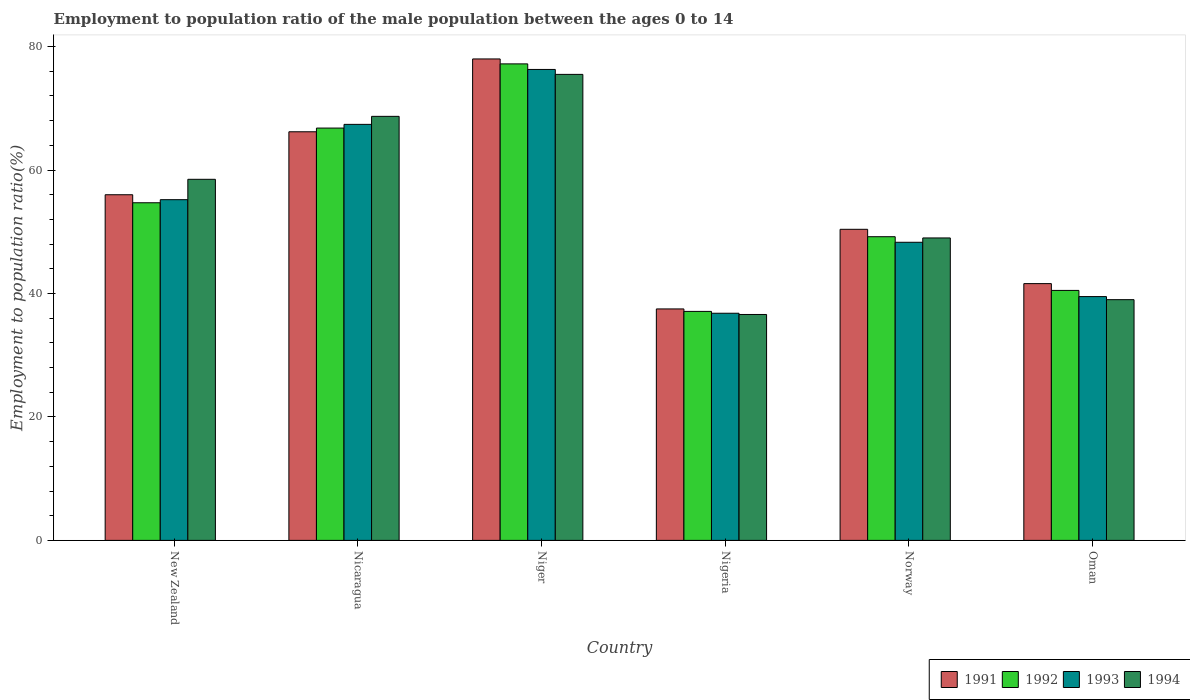How many different coloured bars are there?
Make the answer very short. 4. Are the number of bars per tick equal to the number of legend labels?
Keep it short and to the point. Yes. Are the number of bars on each tick of the X-axis equal?
Your answer should be very brief. Yes. How many bars are there on the 6th tick from the right?
Your response must be concise. 4. What is the label of the 2nd group of bars from the left?
Your response must be concise. Nicaragua. Across all countries, what is the maximum employment to population ratio in 1994?
Give a very brief answer. 75.5. Across all countries, what is the minimum employment to population ratio in 1994?
Your answer should be compact. 36.6. In which country was the employment to population ratio in 1994 maximum?
Keep it short and to the point. Niger. In which country was the employment to population ratio in 1994 minimum?
Your answer should be compact. Nigeria. What is the total employment to population ratio in 1994 in the graph?
Ensure brevity in your answer.  327.3. What is the difference between the employment to population ratio in 1993 in New Zealand and that in Oman?
Make the answer very short. 15.7. What is the difference between the employment to population ratio in 1993 in Nigeria and the employment to population ratio in 1991 in Oman?
Keep it short and to the point. -4.8. What is the average employment to population ratio in 1993 per country?
Your answer should be very brief. 53.92. What is the difference between the employment to population ratio of/in 1991 and employment to population ratio of/in 1993 in Nigeria?
Give a very brief answer. 0.7. What is the ratio of the employment to population ratio in 1993 in Niger to that in Oman?
Offer a terse response. 1.93. What is the difference between the highest and the second highest employment to population ratio in 1992?
Ensure brevity in your answer.  -10.4. What is the difference between the highest and the lowest employment to population ratio in 1993?
Keep it short and to the point. 39.5. In how many countries, is the employment to population ratio in 1994 greater than the average employment to population ratio in 1994 taken over all countries?
Provide a succinct answer. 3. What does the 1st bar from the left in Nicaragua represents?
Offer a very short reply. 1991. Is it the case that in every country, the sum of the employment to population ratio in 1992 and employment to population ratio in 1993 is greater than the employment to population ratio in 1991?
Your answer should be very brief. Yes. How many bars are there?
Make the answer very short. 24. Are all the bars in the graph horizontal?
Keep it short and to the point. No. How many countries are there in the graph?
Provide a succinct answer. 6. How many legend labels are there?
Your answer should be very brief. 4. What is the title of the graph?
Make the answer very short. Employment to population ratio of the male population between the ages 0 to 14. What is the label or title of the X-axis?
Provide a short and direct response. Country. What is the Employment to population ratio(%) in 1992 in New Zealand?
Offer a very short reply. 54.7. What is the Employment to population ratio(%) in 1993 in New Zealand?
Your answer should be compact. 55.2. What is the Employment to population ratio(%) of 1994 in New Zealand?
Your answer should be compact. 58.5. What is the Employment to population ratio(%) of 1991 in Nicaragua?
Your answer should be compact. 66.2. What is the Employment to population ratio(%) in 1992 in Nicaragua?
Make the answer very short. 66.8. What is the Employment to population ratio(%) of 1993 in Nicaragua?
Offer a terse response. 67.4. What is the Employment to population ratio(%) of 1994 in Nicaragua?
Your answer should be very brief. 68.7. What is the Employment to population ratio(%) of 1991 in Niger?
Your response must be concise. 78. What is the Employment to population ratio(%) in 1992 in Niger?
Your answer should be compact. 77.2. What is the Employment to population ratio(%) of 1993 in Niger?
Ensure brevity in your answer.  76.3. What is the Employment to population ratio(%) in 1994 in Niger?
Ensure brevity in your answer.  75.5. What is the Employment to population ratio(%) in 1991 in Nigeria?
Make the answer very short. 37.5. What is the Employment to population ratio(%) in 1992 in Nigeria?
Your answer should be compact. 37.1. What is the Employment to population ratio(%) in 1993 in Nigeria?
Keep it short and to the point. 36.8. What is the Employment to population ratio(%) of 1994 in Nigeria?
Give a very brief answer. 36.6. What is the Employment to population ratio(%) in 1991 in Norway?
Your response must be concise. 50.4. What is the Employment to population ratio(%) of 1992 in Norway?
Your answer should be compact. 49.2. What is the Employment to population ratio(%) of 1993 in Norway?
Ensure brevity in your answer.  48.3. What is the Employment to population ratio(%) in 1994 in Norway?
Offer a very short reply. 49. What is the Employment to population ratio(%) of 1991 in Oman?
Provide a short and direct response. 41.6. What is the Employment to population ratio(%) in 1992 in Oman?
Your answer should be compact. 40.5. What is the Employment to population ratio(%) of 1993 in Oman?
Your response must be concise. 39.5. What is the Employment to population ratio(%) in 1994 in Oman?
Provide a succinct answer. 39. Across all countries, what is the maximum Employment to population ratio(%) of 1991?
Offer a very short reply. 78. Across all countries, what is the maximum Employment to population ratio(%) in 1992?
Your answer should be very brief. 77.2. Across all countries, what is the maximum Employment to population ratio(%) in 1993?
Your answer should be very brief. 76.3. Across all countries, what is the maximum Employment to population ratio(%) of 1994?
Offer a terse response. 75.5. Across all countries, what is the minimum Employment to population ratio(%) in 1991?
Make the answer very short. 37.5. Across all countries, what is the minimum Employment to population ratio(%) in 1992?
Ensure brevity in your answer.  37.1. Across all countries, what is the minimum Employment to population ratio(%) in 1993?
Make the answer very short. 36.8. Across all countries, what is the minimum Employment to population ratio(%) of 1994?
Give a very brief answer. 36.6. What is the total Employment to population ratio(%) in 1991 in the graph?
Your answer should be compact. 329.7. What is the total Employment to population ratio(%) of 1992 in the graph?
Make the answer very short. 325.5. What is the total Employment to population ratio(%) in 1993 in the graph?
Provide a short and direct response. 323.5. What is the total Employment to population ratio(%) of 1994 in the graph?
Offer a very short reply. 327.3. What is the difference between the Employment to population ratio(%) of 1992 in New Zealand and that in Nicaragua?
Your answer should be very brief. -12.1. What is the difference between the Employment to population ratio(%) in 1993 in New Zealand and that in Nicaragua?
Keep it short and to the point. -12.2. What is the difference between the Employment to population ratio(%) of 1994 in New Zealand and that in Nicaragua?
Provide a succinct answer. -10.2. What is the difference between the Employment to population ratio(%) in 1992 in New Zealand and that in Niger?
Your answer should be very brief. -22.5. What is the difference between the Employment to population ratio(%) in 1993 in New Zealand and that in Niger?
Your response must be concise. -21.1. What is the difference between the Employment to population ratio(%) in 1994 in New Zealand and that in Nigeria?
Your response must be concise. 21.9. What is the difference between the Employment to population ratio(%) of 1993 in New Zealand and that in Norway?
Offer a terse response. 6.9. What is the difference between the Employment to population ratio(%) in 1994 in New Zealand and that in Norway?
Offer a very short reply. 9.5. What is the difference between the Employment to population ratio(%) of 1992 in New Zealand and that in Oman?
Your answer should be very brief. 14.2. What is the difference between the Employment to population ratio(%) of 1993 in New Zealand and that in Oman?
Keep it short and to the point. 15.7. What is the difference between the Employment to population ratio(%) of 1993 in Nicaragua and that in Niger?
Provide a succinct answer. -8.9. What is the difference between the Employment to population ratio(%) of 1994 in Nicaragua and that in Niger?
Your answer should be compact. -6.8. What is the difference between the Employment to population ratio(%) of 1991 in Nicaragua and that in Nigeria?
Keep it short and to the point. 28.7. What is the difference between the Employment to population ratio(%) of 1992 in Nicaragua and that in Nigeria?
Provide a short and direct response. 29.7. What is the difference between the Employment to population ratio(%) in 1993 in Nicaragua and that in Nigeria?
Offer a terse response. 30.6. What is the difference between the Employment to population ratio(%) of 1994 in Nicaragua and that in Nigeria?
Offer a very short reply. 32.1. What is the difference between the Employment to population ratio(%) in 1991 in Nicaragua and that in Norway?
Offer a terse response. 15.8. What is the difference between the Employment to population ratio(%) of 1993 in Nicaragua and that in Norway?
Your answer should be compact. 19.1. What is the difference between the Employment to population ratio(%) of 1994 in Nicaragua and that in Norway?
Offer a terse response. 19.7. What is the difference between the Employment to population ratio(%) of 1991 in Nicaragua and that in Oman?
Give a very brief answer. 24.6. What is the difference between the Employment to population ratio(%) of 1992 in Nicaragua and that in Oman?
Offer a very short reply. 26.3. What is the difference between the Employment to population ratio(%) in 1993 in Nicaragua and that in Oman?
Your answer should be compact. 27.9. What is the difference between the Employment to population ratio(%) of 1994 in Nicaragua and that in Oman?
Give a very brief answer. 29.7. What is the difference between the Employment to population ratio(%) of 1991 in Niger and that in Nigeria?
Keep it short and to the point. 40.5. What is the difference between the Employment to population ratio(%) of 1992 in Niger and that in Nigeria?
Keep it short and to the point. 40.1. What is the difference between the Employment to population ratio(%) in 1993 in Niger and that in Nigeria?
Provide a succinct answer. 39.5. What is the difference between the Employment to population ratio(%) in 1994 in Niger and that in Nigeria?
Make the answer very short. 38.9. What is the difference between the Employment to population ratio(%) in 1991 in Niger and that in Norway?
Offer a very short reply. 27.6. What is the difference between the Employment to population ratio(%) in 1994 in Niger and that in Norway?
Offer a very short reply. 26.5. What is the difference between the Employment to population ratio(%) of 1991 in Niger and that in Oman?
Keep it short and to the point. 36.4. What is the difference between the Employment to population ratio(%) in 1992 in Niger and that in Oman?
Provide a succinct answer. 36.7. What is the difference between the Employment to population ratio(%) in 1993 in Niger and that in Oman?
Your response must be concise. 36.8. What is the difference between the Employment to population ratio(%) of 1994 in Niger and that in Oman?
Give a very brief answer. 36.5. What is the difference between the Employment to population ratio(%) of 1991 in Nigeria and that in Norway?
Your answer should be compact. -12.9. What is the difference between the Employment to population ratio(%) in 1992 in Nigeria and that in Norway?
Your response must be concise. -12.1. What is the difference between the Employment to population ratio(%) of 1991 in Nigeria and that in Oman?
Offer a very short reply. -4.1. What is the difference between the Employment to population ratio(%) in 1992 in Nigeria and that in Oman?
Offer a very short reply. -3.4. What is the difference between the Employment to population ratio(%) in 1993 in Norway and that in Oman?
Your response must be concise. 8.8. What is the difference between the Employment to population ratio(%) in 1994 in Norway and that in Oman?
Keep it short and to the point. 10. What is the difference between the Employment to population ratio(%) of 1991 in New Zealand and the Employment to population ratio(%) of 1992 in Nicaragua?
Offer a terse response. -10.8. What is the difference between the Employment to population ratio(%) of 1992 in New Zealand and the Employment to population ratio(%) of 1993 in Nicaragua?
Offer a very short reply. -12.7. What is the difference between the Employment to population ratio(%) of 1992 in New Zealand and the Employment to population ratio(%) of 1994 in Nicaragua?
Give a very brief answer. -14. What is the difference between the Employment to population ratio(%) in 1991 in New Zealand and the Employment to population ratio(%) in 1992 in Niger?
Your answer should be very brief. -21.2. What is the difference between the Employment to population ratio(%) of 1991 in New Zealand and the Employment to population ratio(%) of 1993 in Niger?
Your answer should be very brief. -20.3. What is the difference between the Employment to population ratio(%) of 1991 in New Zealand and the Employment to population ratio(%) of 1994 in Niger?
Offer a very short reply. -19.5. What is the difference between the Employment to population ratio(%) of 1992 in New Zealand and the Employment to population ratio(%) of 1993 in Niger?
Offer a terse response. -21.6. What is the difference between the Employment to population ratio(%) in 1992 in New Zealand and the Employment to population ratio(%) in 1994 in Niger?
Provide a short and direct response. -20.8. What is the difference between the Employment to population ratio(%) of 1993 in New Zealand and the Employment to population ratio(%) of 1994 in Niger?
Your answer should be very brief. -20.3. What is the difference between the Employment to population ratio(%) of 1991 in New Zealand and the Employment to population ratio(%) of 1992 in Nigeria?
Offer a terse response. 18.9. What is the difference between the Employment to population ratio(%) in 1991 in New Zealand and the Employment to population ratio(%) in 1994 in Nigeria?
Offer a terse response. 19.4. What is the difference between the Employment to population ratio(%) in 1992 in New Zealand and the Employment to population ratio(%) in 1994 in Nigeria?
Offer a terse response. 18.1. What is the difference between the Employment to population ratio(%) in 1993 in New Zealand and the Employment to population ratio(%) in 1994 in Nigeria?
Make the answer very short. 18.6. What is the difference between the Employment to population ratio(%) of 1991 in New Zealand and the Employment to population ratio(%) of 1993 in Norway?
Offer a very short reply. 7.7. What is the difference between the Employment to population ratio(%) in 1991 in New Zealand and the Employment to population ratio(%) in 1992 in Oman?
Provide a short and direct response. 15.5. What is the difference between the Employment to population ratio(%) of 1992 in New Zealand and the Employment to population ratio(%) of 1993 in Oman?
Offer a terse response. 15.2. What is the difference between the Employment to population ratio(%) in 1991 in Nicaragua and the Employment to population ratio(%) in 1992 in Niger?
Offer a very short reply. -11. What is the difference between the Employment to population ratio(%) in 1991 in Nicaragua and the Employment to population ratio(%) in 1993 in Niger?
Offer a very short reply. -10.1. What is the difference between the Employment to population ratio(%) in 1992 in Nicaragua and the Employment to population ratio(%) in 1993 in Niger?
Give a very brief answer. -9.5. What is the difference between the Employment to population ratio(%) in 1991 in Nicaragua and the Employment to population ratio(%) in 1992 in Nigeria?
Your answer should be compact. 29.1. What is the difference between the Employment to population ratio(%) in 1991 in Nicaragua and the Employment to population ratio(%) in 1993 in Nigeria?
Your response must be concise. 29.4. What is the difference between the Employment to population ratio(%) in 1991 in Nicaragua and the Employment to population ratio(%) in 1994 in Nigeria?
Offer a very short reply. 29.6. What is the difference between the Employment to population ratio(%) in 1992 in Nicaragua and the Employment to population ratio(%) in 1994 in Nigeria?
Give a very brief answer. 30.2. What is the difference between the Employment to population ratio(%) in 1993 in Nicaragua and the Employment to population ratio(%) in 1994 in Nigeria?
Ensure brevity in your answer.  30.8. What is the difference between the Employment to population ratio(%) in 1991 in Nicaragua and the Employment to population ratio(%) in 1993 in Norway?
Provide a succinct answer. 17.9. What is the difference between the Employment to population ratio(%) in 1992 in Nicaragua and the Employment to population ratio(%) in 1994 in Norway?
Offer a very short reply. 17.8. What is the difference between the Employment to population ratio(%) in 1993 in Nicaragua and the Employment to population ratio(%) in 1994 in Norway?
Make the answer very short. 18.4. What is the difference between the Employment to population ratio(%) of 1991 in Nicaragua and the Employment to population ratio(%) of 1992 in Oman?
Your response must be concise. 25.7. What is the difference between the Employment to population ratio(%) in 1991 in Nicaragua and the Employment to population ratio(%) in 1993 in Oman?
Offer a very short reply. 26.7. What is the difference between the Employment to population ratio(%) in 1991 in Nicaragua and the Employment to population ratio(%) in 1994 in Oman?
Ensure brevity in your answer.  27.2. What is the difference between the Employment to population ratio(%) in 1992 in Nicaragua and the Employment to population ratio(%) in 1993 in Oman?
Provide a short and direct response. 27.3. What is the difference between the Employment to population ratio(%) of 1992 in Nicaragua and the Employment to population ratio(%) of 1994 in Oman?
Your answer should be very brief. 27.8. What is the difference between the Employment to population ratio(%) in 1993 in Nicaragua and the Employment to population ratio(%) in 1994 in Oman?
Your answer should be very brief. 28.4. What is the difference between the Employment to population ratio(%) in 1991 in Niger and the Employment to population ratio(%) in 1992 in Nigeria?
Your answer should be compact. 40.9. What is the difference between the Employment to population ratio(%) in 1991 in Niger and the Employment to population ratio(%) in 1993 in Nigeria?
Ensure brevity in your answer.  41.2. What is the difference between the Employment to population ratio(%) in 1991 in Niger and the Employment to population ratio(%) in 1994 in Nigeria?
Make the answer very short. 41.4. What is the difference between the Employment to population ratio(%) of 1992 in Niger and the Employment to population ratio(%) of 1993 in Nigeria?
Your response must be concise. 40.4. What is the difference between the Employment to population ratio(%) in 1992 in Niger and the Employment to population ratio(%) in 1994 in Nigeria?
Ensure brevity in your answer.  40.6. What is the difference between the Employment to population ratio(%) in 1993 in Niger and the Employment to population ratio(%) in 1994 in Nigeria?
Your answer should be very brief. 39.7. What is the difference between the Employment to population ratio(%) of 1991 in Niger and the Employment to population ratio(%) of 1992 in Norway?
Keep it short and to the point. 28.8. What is the difference between the Employment to population ratio(%) of 1991 in Niger and the Employment to population ratio(%) of 1993 in Norway?
Make the answer very short. 29.7. What is the difference between the Employment to population ratio(%) of 1991 in Niger and the Employment to population ratio(%) of 1994 in Norway?
Your answer should be compact. 29. What is the difference between the Employment to population ratio(%) of 1992 in Niger and the Employment to population ratio(%) of 1993 in Norway?
Ensure brevity in your answer.  28.9. What is the difference between the Employment to population ratio(%) in 1992 in Niger and the Employment to population ratio(%) in 1994 in Norway?
Keep it short and to the point. 28.2. What is the difference between the Employment to population ratio(%) in 1993 in Niger and the Employment to population ratio(%) in 1994 in Norway?
Keep it short and to the point. 27.3. What is the difference between the Employment to population ratio(%) of 1991 in Niger and the Employment to population ratio(%) of 1992 in Oman?
Make the answer very short. 37.5. What is the difference between the Employment to population ratio(%) of 1991 in Niger and the Employment to population ratio(%) of 1993 in Oman?
Provide a succinct answer. 38.5. What is the difference between the Employment to population ratio(%) in 1992 in Niger and the Employment to population ratio(%) in 1993 in Oman?
Offer a terse response. 37.7. What is the difference between the Employment to population ratio(%) of 1992 in Niger and the Employment to population ratio(%) of 1994 in Oman?
Your answer should be very brief. 38.2. What is the difference between the Employment to population ratio(%) of 1993 in Niger and the Employment to population ratio(%) of 1994 in Oman?
Your answer should be compact. 37.3. What is the difference between the Employment to population ratio(%) in 1991 in Nigeria and the Employment to population ratio(%) in 1993 in Norway?
Offer a terse response. -10.8. What is the difference between the Employment to population ratio(%) of 1992 in Nigeria and the Employment to population ratio(%) of 1994 in Norway?
Give a very brief answer. -11.9. What is the difference between the Employment to population ratio(%) in 1993 in Nigeria and the Employment to population ratio(%) in 1994 in Norway?
Your answer should be compact. -12.2. What is the difference between the Employment to population ratio(%) of 1991 in Nigeria and the Employment to population ratio(%) of 1994 in Oman?
Give a very brief answer. -1.5. What is the difference between the Employment to population ratio(%) in 1992 in Nigeria and the Employment to population ratio(%) in 1994 in Oman?
Keep it short and to the point. -1.9. What is the difference between the Employment to population ratio(%) in 1991 in Norway and the Employment to population ratio(%) in 1992 in Oman?
Keep it short and to the point. 9.9. What is the difference between the Employment to population ratio(%) in 1991 in Norway and the Employment to population ratio(%) in 1993 in Oman?
Your answer should be very brief. 10.9. What is the difference between the Employment to population ratio(%) of 1992 in Norway and the Employment to population ratio(%) of 1993 in Oman?
Your response must be concise. 9.7. What is the average Employment to population ratio(%) in 1991 per country?
Give a very brief answer. 54.95. What is the average Employment to population ratio(%) of 1992 per country?
Make the answer very short. 54.25. What is the average Employment to population ratio(%) of 1993 per country?
Provide a succinct answer. 53.92. What is the average Employment to population ratio(%) of 1994 per country?
Your answer should be very brief. 54.55. What is the difference between the Employment to population ratio(%) in 1991 and Employment to population ratio(%) in 1992 in New Zealand?
Your response must be concise. 1.3. What is the difference between the Employment to population ratio(%) in 1991 and Employment to population ratio(%) in 1993 in New Zealand?
Provide a short and direct response. 0.8. What is the difference between the Employment to population ratio(%) in 1991 and Employment to population ratio(%) in 1994 in New Zealand?
Give a very brief answer. -2.5. What is the difference between the Employment to population ratio(%) in 1992 and Employment to population ratio(%) in 1993 in New Zealand?
Give a very brief answer. -0.5. What is the difference between the Employment to population ratio(%) in 1993 and Employment to population ratio(%) in 1994 in New Zealand?
Provide a succinct answer. -3.3. What is the difference between the Employment to population ratio(%) in 1991 and Employment to population ratio(%) in 1992 in Nicaragua?
Offer a very short reply. -0.6. What is the difference between the Employment to population ratio(%) in 1991 and Employment to population ratio(%) in 1994 in Nicaragua?
Provide a short and direct response. -2.5. What is the difference between the Employment to population ratio(%) in 1993 and Employment to population ratio(%) in 1994 in Nicaragua?
Make the answer very short. -1.3. What is the difference between the Employment to population ratio(%) of 1992 and Employment to population ratio(%) of 1993 in Niger?
Ensure brevity in your answer.  0.9. What is the difference between the Employment to population ratio(%) of 1992 and Employment to population ratio(%) of 1994 in Niger?
Provide a succinct answer. 1.7. What is the difference between the Employment to population ratio(%) of 1991 and Employment to population ratio(%) of 1992 in Nigeria?
Your answer should be very brief. 0.4. What is the difference between the Employment to population ratio(%) of 1991 and Employment to population ratio(%) of 1993 in Nigeria?
Ensure brevity in your answer.  0.7. What is the difference between the Employment to population ratio(%) in 1991 and Employment to population ratio(%) in 1994 in Norway?
Give a very brief answer. 1.4. What is the difference between the Employment to population ratio(%) in 1992 and Employment to population ratio(%) in 1993 in Norway?
Provide a succinct answer. 0.9. What is the difference between the Employment to population ratio(%) of 1993 and Employment to population ratio(%) of 1994 in Norway?
Offer a very short reply. -0.7. What is the difference between the Employment to population ratio(%) in 1991 and Employment to population ratio(%) in 1992 in Oman?
Provide a succinct answer. 1.1. What is the difference between the Employment to population ratio(%) of 1992 and Employment to population ratio(%) of 1993 in Oman?
Offer a terse response. 1. What is the difference between the Employment to population ratio(%) of 1992 and Employment to population ratio(%) of 1994 in Oman?
Make the answer very short. 1.5. What is the difference between the Employment to population ratio(%) of 1993 and Employment to population ratio(%) of 1994 in Oman?
Offer a terse response. 0.5. What is the ratio of the Employment to population ratio(%) of 1991 in New Zealand to that in Nicaragua?
Provide a succinct answer. 0.85. What is the ratio of the Employment to population ratio(%) of 1992 in New Zealand to that in Nicaragua?
Your response must be concise. 0.82. What is the ratio of the Employment to population ratio(%) of 1993 in New Zealand to that in Nicaragua?
Offer a very short reply. 0.82. What is the ratio of the Employment to population ratio(%) of 1994 in New Zealand to that in Nicaragua?
Your response must be concise. 0.85. What is the ratio of the Employment to population ratio(%) of 1991 in New Zealand to that in Niger?
Offer a terse response. 0.72. What is the ratio of the Employment to population ratio(%) of 1992 in New Zealand to that in Niger?
Provide a short and direct response. 0.71. What is the ratio of the Employment to population ratio(%) of 1993 in New Zealand to that in Niger?
Your answer should be very brief. 0.72. What is the ratio of the Employment to population ratio(%) of 1994 in New Zealand to that in Niger?
Your answer should be very brief. 0.77. What is the ratio of the Employment to population ratio(%) in 1991 in New Zealand to that in Nigeria?
Give a very brief answer. 1.49. What is the ratio of the Employment to population ratio(%) in 1992 in New Zealand to that in Nigeria?
Your answer should be very brief. 1.47. What is the ratio of the Employment to population ratio(%) of 1993 in New Zealand to that in Nigeria?
Ensure brevity in your answer.  1.5. What is the ratio of the Employment to population ratio(%) of 1994 in New Zealand to that in Nigeria?
Make the answer very short. 1.6. What is the ratio of the Employment to population ratio(%) in 1992 in New Zealand to that in Norway?
Ensure brevity in your answer.  1.11. What is the ratio of the Employment to population ratio(%) in 1994 in New Zealand to that in Norway?
Give a very brief answer. 1.19. What is the ratio of the Employment to population ratio(%) in 1991 in New Zealand to that in Oman?
Provide a short and direct response. 1.35. What is the ratio of the Employment to population ratio(%) of 1992 in New Zealand to that in Oman?
Offer a terse response. 1.35. What is the ratio of the Employment to population ratio(%) in 1993 in New Zealand to that in Oman?
Your answer should be very brief. 1.4. What is the ratio of the Employment to population ratio(%) of 1994 in New Zealand to that in Oman?
Provide a succinct answer. 1.5. What is the ratio of the Employment to population ratio(%) of 1991 in Nicaragua to that in Niger?
Your response must be concise. 0.85. What is the ratio of the Employment to population ratio(%) in 1992 in Nicaragua to that in Niger?
Provide a succinct answer. 0.87. What is the ratio of the Employment to population ratio(%) in 1993 in Nicaragua to that in Niger?
Provide a short and direct response. 0.88. What is the ratio of the Employment to population ratio(%) in 1994 in Nicaragua to that in Niger?
Your response must be concise. 0.91. What is the ratio of the Employment to population ratio(%) of 1991 in Nicaragua to that in Nigeria?
Give a very brief answer. 1.77. What is the ratio of the Employment to population ratio(%) of 1992 in Nicaragua to that in Nigeria?
Provide a succinct answer. 1.8. What is the ratio of the Employment to population ratio(%) in 1993 in Nicaragua to that in Nigeria?
Offer a terse response. 1.83. What is the ratio of the Employment to population ratio(%) in 1994 in Nicaragua to that in Nigeria?
Provide a short and direct response. 1.88. What is the ratio of the Employment to population ratio(%) in 1991 in Nicaragua to that in Norway?
Ensure brevity in your answer.  1.31. What is the ratio of the Employment to population ratio(%) in 1992 in Nicaragua to that in Norway?
Your answer should be compact. 1.36. What is the ratio of the Employment to population ratio(%) of 1993 in Nicaragua to that in Norway?
Offer a very short reply. 1.4. What is the ratio of the Employment to population ratio(%) in 1994 in Nicaragua to that in Norway?
Ensure brevity in your answer.  1.4. What is the ratio of the Employment to population ratio(%) of 1991 in Nicaragua to that in Oman?
Keep it short and to the point. 1.59. What is the ratio of the Employment to population ratio(%) of 1992 in Nicaragua to that in Oman?
Your answer should be very brief. 1.65. What is the ratio of the Employment to population ratio(%) of 1993 in Nicaragua to that in Oman?
Make the answer very short. 1.71. What is the ratio of the Employment to population ratio(%) in 1994 in Nicaragua to that in Oman?
Your answer should be compact. 1.76. What is the ratio of the Employment to population ratio(%) in 1991 in Niger to that in Nigeria?
Your answer should be compact. 2.08. What is the ratio of the Employment to population ratio(%) in 1992 in Niger to that in Nigeria?
Provide a succinct answer. 2.08. What is the ratio of the Employment to population ratio(%) of 1993 in Niger to that in Nigeria?
Keep it short and to the point. 2.07. What is the ratio of the Employment to population ratio(%) of 1994 in Niger to that in Nigeria?
Give a very brief answer. 2.06. What is the ratio of the Employment to population ratio(%) in 1991 in Niger to that in Norway?
Your response must be concise. 1.55. What is the ratio of the Employment to population ratio(%) of 1992 in Niger to that in Norway?
Ensure brevity in your answer.  1.57. What is the ratio of the Employment to population ratio(%) of 1993 in Niger to that in Norway?
Offer a terse response. 1.58. What is the ratio of the Employment to population ratio(%) of 1994 in Niger to that in Norway?
Provide a succinct answer. 1.54. What is the ratio of the Employment to population ratio(%) of 1991 in Niger to that in Oman?
Your answer should be compact. 1.88. What is the ratio of the Employment to population ratio(%) in 1992 in Niger to that in Oman?
Your response must be concise. 1.91. What is the ratio of the Employment to population ratio(%) of 1993 in Niger to that in Oman?
Ensure brevity in your answer.  1.93. What is the ratio of the Employment to population ratio(%) of 1994 in Niger to that in Oman?
Provide a succinct answer. 1.94. What is the ratio of the Employment to population ratio(%) of 1991 in Nigeria to that in Norway?
Provide a succinct answer. 0.74. What is the ratio of the Employment to population ratio(%) in 1992 in Nigeria to that in Norway?
Keep it short and to the point. 0.75. What is the ratio of the Employment to population ratio(%) of 1993 in Nigeria to that in Norway?
Provide a succinct answer. 0.76. What is the ratio of the Employment to population ratio(%) in 1994 in Nigeria to that in Norway?
Your answer should be compact. 0.75. What is the ratio of the Employment to population ratio(%) in 1991 in Nigeria to that in Oman?
Give a very brief answer. 0.9. What is the ratio of the Employment to population ratio(%) of 1992 in Nigeria to that in Oman?
Offer a very short reply. 0.92. What is the ratio of the Employment to population ratio(%) in 1993 in Nigeria to that in Oman?
Your response must be concise. 0.93. What is the ratio of the Employment to population ratio(%) of 1994 in Nigeria to that in Oman?
Offer a terse response. 0.94. What is the ratio of the Employment to population ratio(%) of 1991 in Norway to that in Oman?
Ensure brevity in your answer.  1.21. What is the ratio of the Employment to population ratio(%) in 1992 in Norway to that in Oman?
Ensure brevity in your answer.  1.21. What is the ratio of the Employment to population ratio(%) of 1993 in Norway to that in Oman?
Provide a short and direct response. 1.22. What is the ratio of the Employment to population ratio(%) of 1994 in Norway to that in Oman?
Make the answer very short. 1.26. What is the difference between the highest and the lowest Employment to population ratio(%) of 1991?
Offer a terse response. 40.5. What is the difference between the highest and the lowest Employment to population ratio(%) of 1992?
Your answer should be very brief. 40.1. What is the difference between the highest and the lowest Employment to population ratio(%) in 1993?
Give a very brief answer. 39.5. What is the difference between the highest and the lowest Employment to population ratio(%) in 1994?
Ensure brevity in your answer.  38.9. 